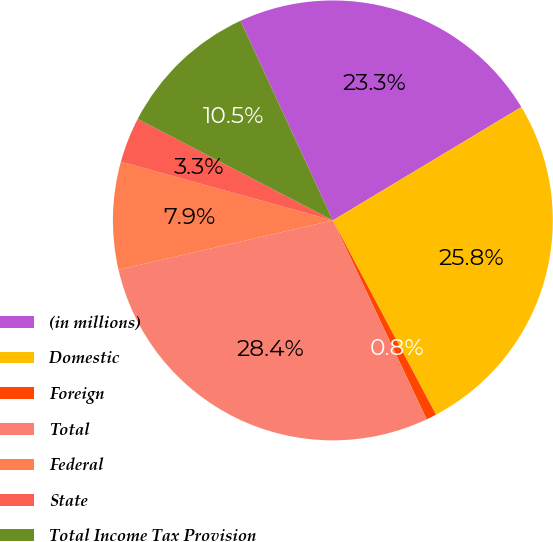Convert chart to OTSL. <chart><loc_0><loc_0><loc_500><loc_500><pie_chart><fcel>(in millions)<fcel>Domestic<fcel>Foreign<fcel>Total<fcel>Federal<fcel>State<fcel>Total Income Tax Provision<nl><fcel>23.28%<fcel>25.85%<fcel>0.76%<fcel>28.41%<fcel>7.9%<fcel>3.33%<fcel>10.47%<nl></chart> 